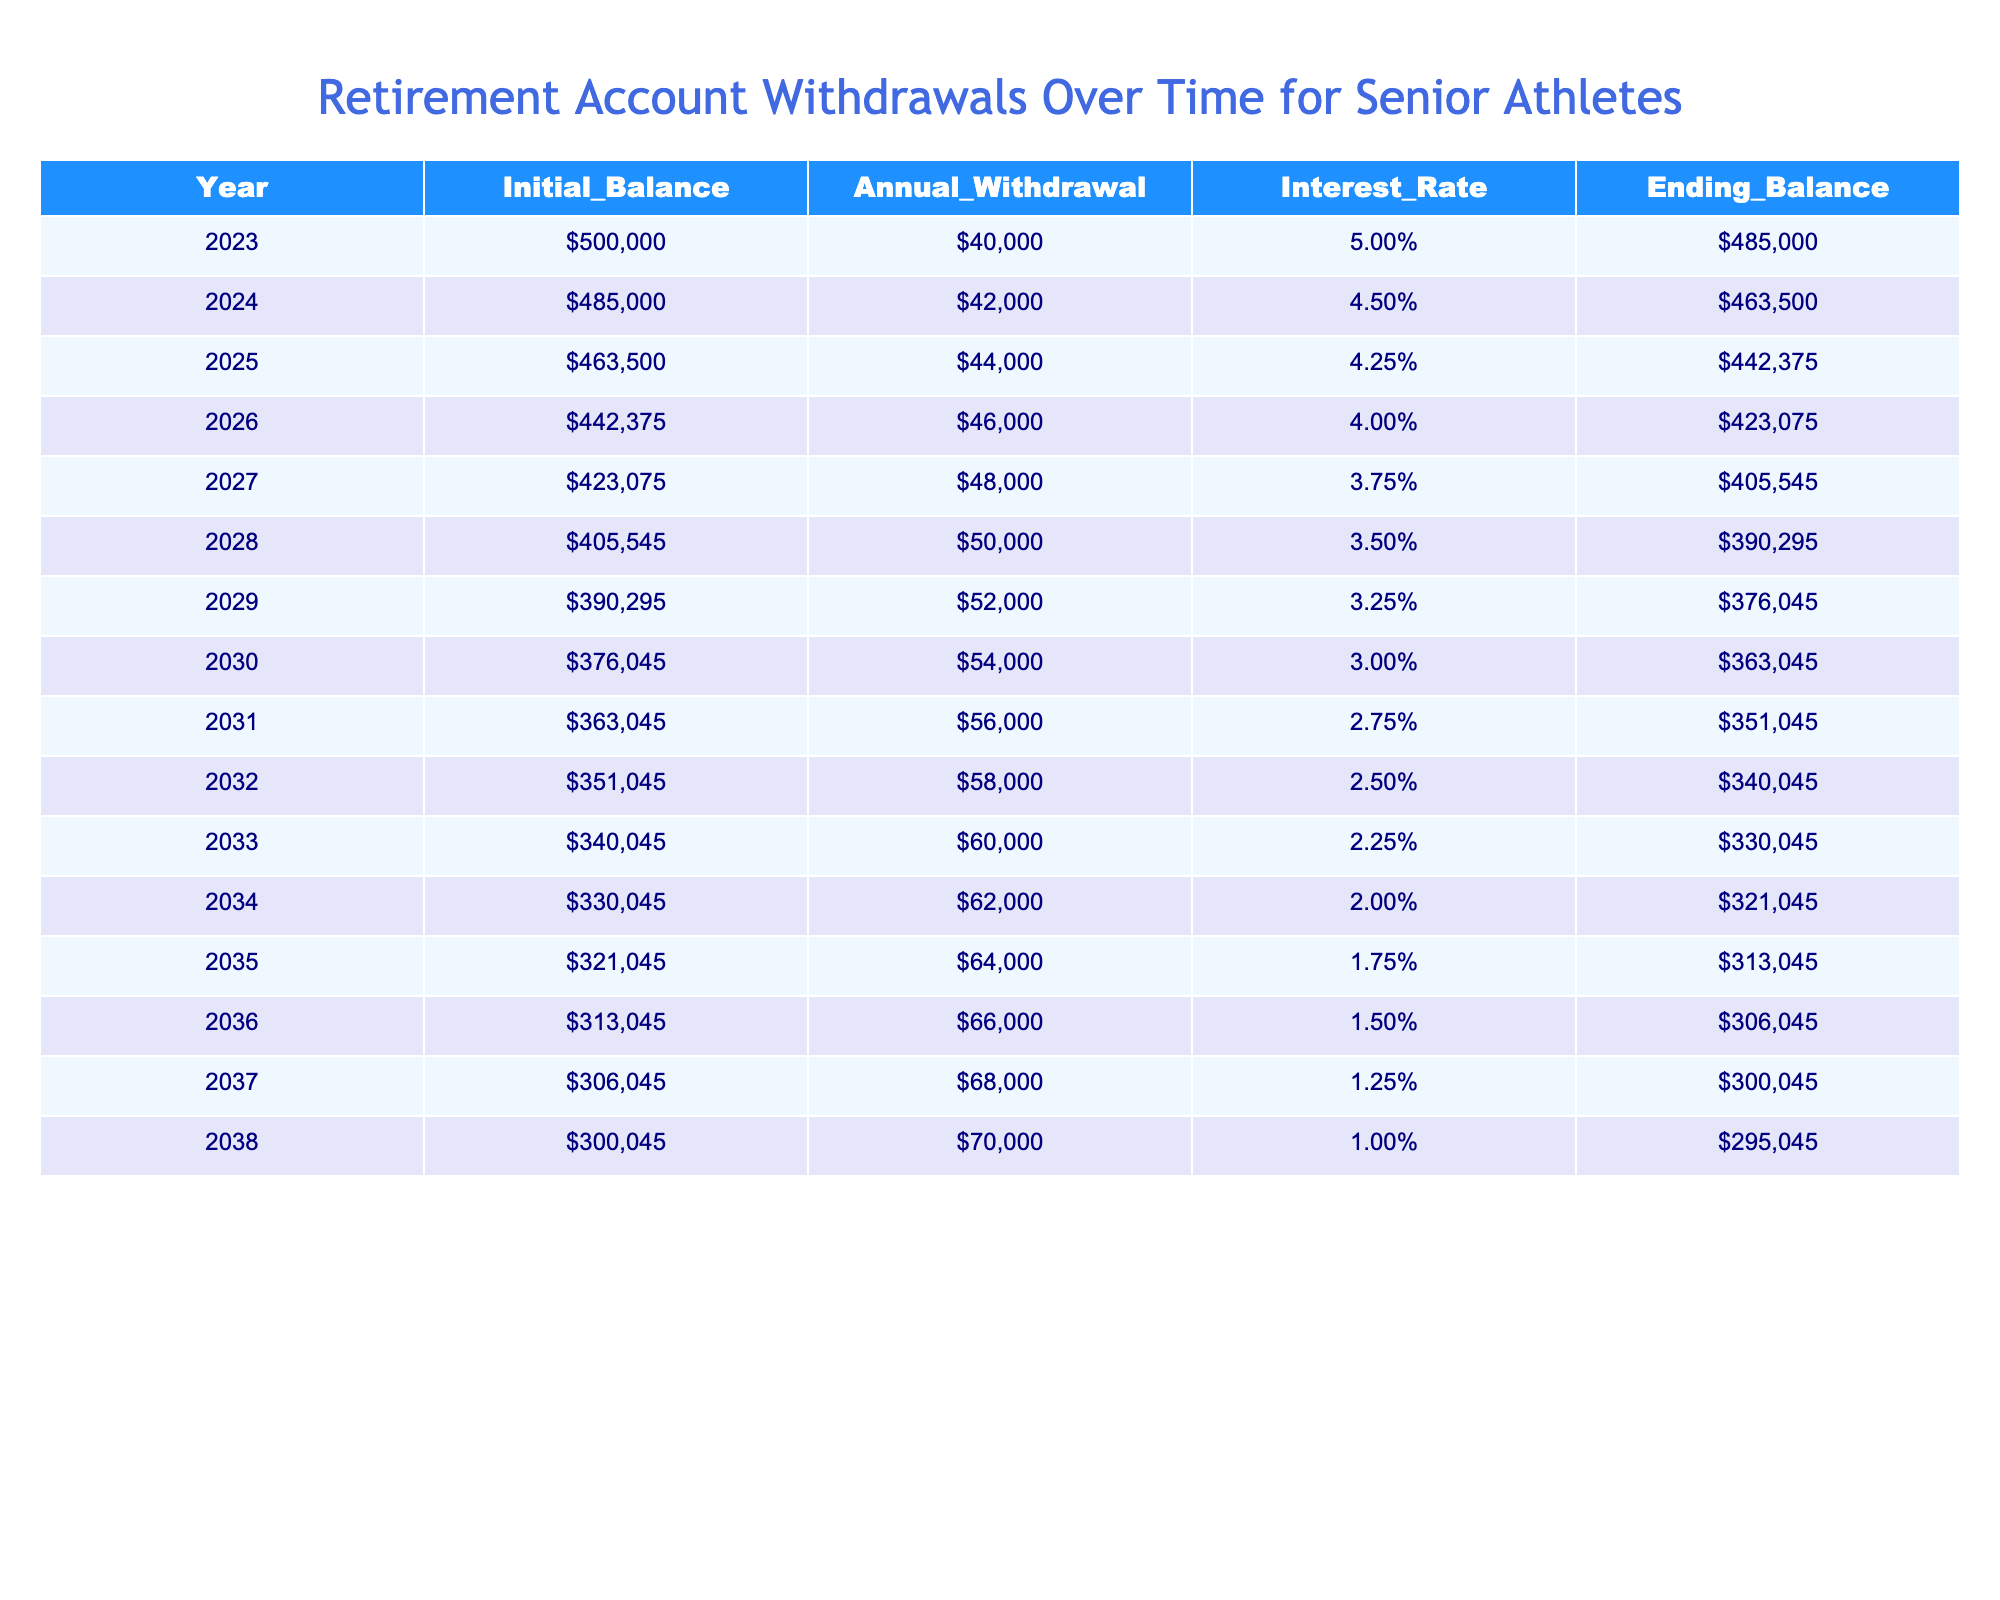What is the annual withdrawal amount for the year 2025? In the table, we can look at the row for the year 2025, which shows an annual withdrawal amount of $44,000.
Answer: $44,000 What was the ending balance in 2030? The ending balance for the year 2030 is found in the corresponding row, which states it is $363,045.
Answer: $363,045 Is the interest rate for 2023 higher than the interest rate for 2038? By comparing the two years, 2023 has an interest rate of 5.00% and 2038 has an interest rate of 1.00%. Since 5.00% is greater than 1.00%, the statement is true.
Answer: Yes What is the total amount withdrawn over the years from 2023 to 2030? We sum the annual withdrawals from each year: 40,000 + 42,000 + 44,000 + 46,000 + 48,000 + 50,000 + 52,000 + 54,000 = 376,000.
Answer: $376,000 In which year did the ending balance first fall below $310,000? We examine the ending balances each year: they fall below $310,000 for the first time in the year 2036, where it is $306,045.
Answer: 2036 